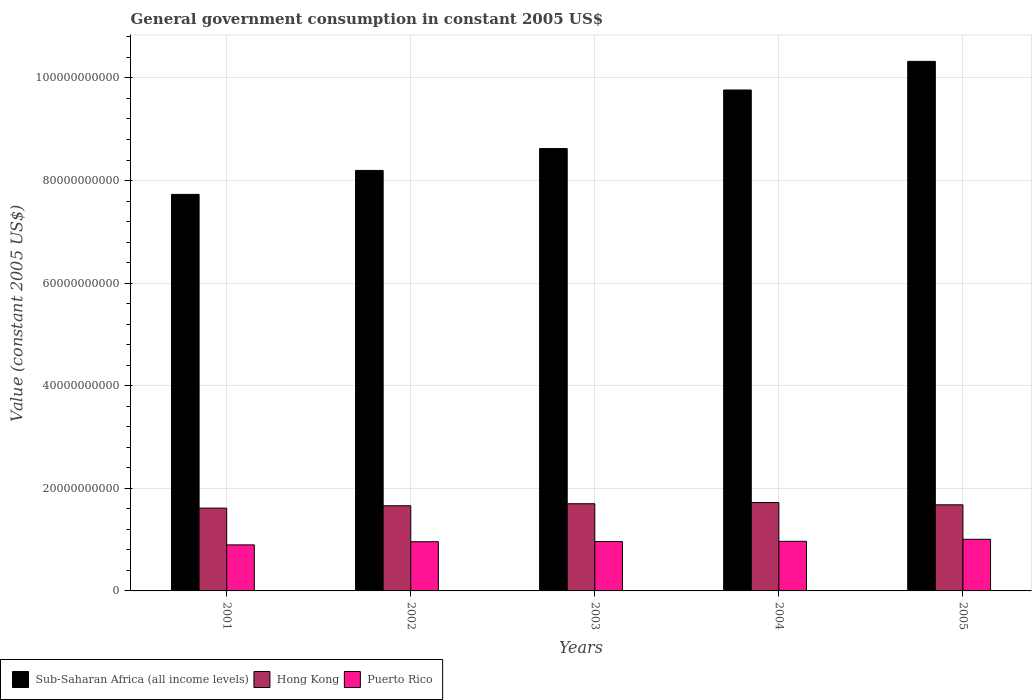How many bars are there on the 1st tick from the left?
Offer a very short reply. 3. What is the label of the 3rd group of bars from the left?
Provide a succinct answer. 2003. In how many cases, is the number of bars for a given year not equal to the number of legend labels?
Provide a succinct answer. 0. What is the government conusmption in Sub-Saharan Africa (all income levels) in 2003?
Give a very brief answer. 8.62e+1. Across all years, what is the maximum government conusmption in Sub-Saharan Africa (all income levels)?
Give a very brief answer. 1.03e+11. Across all years, what is the minimum government conusmption in Hong Kong?
Provide a succinct answer. 1.61e+1. In which year was the government conusmption in Sub-Saharan Africa (all income levels) maximum?
Ensure brevity in your answer.  2005. In which year was the government conusmption in Sub-Saharan Africa (all income levels) minimum?
Provide a succinct answer. 2001. What is the total government conusmption in Sub-Saharan Africa (all income levels) in the graph?
Provide a succinct answer. 4.46e+11. What is the difference between the government conusmption in Puerto Rico in 2003 and that in 2005?
Your answer should be very brief. -4.51e+08. What is the difference between the government conusmption in Sub-Saharan Africa (all income levels) in 2005 and the government conusmption in Hong Kong in 2002?
Keep it short and to the point. 8.66e+1. What is the average government conusmption in Hong Kong per year?
Give a very brief answer. 1.68e+1. In the year 2001, what is the difference between the government conusmption in Hong Kong and government conusmption in Puerto Rico?
Give a very brief answer. 7.16e+09. In how many years, is the government conusmption in Hong Kong greater than 104000000000 US$?
Your answer should be very brief. 0. What is the ratio of the government conusmption in Puerto Rico in 2002 to that in 2005?
Your answer should be very brief. 0.95. What is the difference between the highest and the second highest government conusmption in Puerto Rico?
Ensure brevity in your answer.  3.96e+08. What is the difference between the highest and the lowest government conusmption in Puerto Rico?
Your response must be concise. 1.09e+09. In how many years, is the government conusmption in Puerto Rico greater than the average government conusmption in Puerto Rico taken over all years?
Provide a succinct answer. 4. Is the sum of the government conusmption in Puerto Rico in 2003 and 2004 greater than the maximum government conusmption in Hong Kong across all years?
Your response must be concise. Yes. What does the 2nd bar from the left in 2001 represents?
Offer a terse response. Hong Kong. What does the 3rd bar from the right in 2003 represents?
Keep it short and to the point. Sub-Saharan Africa (all income levels). How many bars are there?
Give a very brief answer. 15. Are all the bars in the graph horizontal?
Your response must be concise. No. Does the graph contain any zero values?
Ensure brevity in your answer.  No. Where does the legend appear in the graph?
Offer a terse response. Bottom left. What is the title of the graph?
Provide a succinct answer. General government consumption in constant 2005 US$. Does "El Salvador" appear as one of the legend labels in the graph?
Ensure brevity in your answer.  No. What is the label or title of the X-axis?
Your answer should be very brief. Years. What is the label or title of the Y-axis?
Keep it short and to the point. Value (constant 2005 US$). What is the Value (constant 2005 US$) in Sub-Saharan Africa (all income levels) in 2001?
Your answer should be very brief. 7.73e+1. What is the Value (constant 2005 US$) in Hong Kong in 2001?
Offer a very short reply. 1.61e+1. What is the Value (constant 2005 US$) in Puerto Rico in 2001?
Offer a very short reply. 8.97e+09. What is the Value (constant 2005 US$) of Sub-Saharan Africa (all income levels) in 2002?
Your response must be concise. 8.20e+1. What is the Value (constant 2005 US$) in Hong Kong in 2002?
Give a very brief answer. 1.66e+1. What is the Value (constant 2005 US$) in Puerto Rico in 2002?
Offer a very short reply. 9.59e+09. What is the Value (constant 2005 US$) of Sub-Saharan Africa (all income levels) in 2003?
Keep it short and to the point. 8.62e+1. What is the Value (constant 2005 US$) in Hong Kong in 2003?
Ensure brevity in your answer.  1.70e+1. What is the Value (constant 2005 US$) in Puerto Rico in 2003?
Ensure brevity in your answer.  9.61e+09. What is the Value (constant 2005 US$) in Sub-Saharan Africa (all income levels) in 2004?
Give a very brief answer. 9.77e+1. What is the Value (constant 2005 US$) of Hong Kong in 2004?
Provide a short and direct response. 1.72e+1. What is the Value (constant 2005 US$) of Puerto Rico in 2004?
Offer a terse response. 9.67e+09. What is the Value (constant 2005 US$) in Sub-Saharan Africa (all income levels) in 2005?
Your response must be concise. 1.03e+11. What is the Value (constant 2005 US$) in Hong Kong in 2005?
Your response must be concise. 1.68e+1. What is the Value (constant 2005 US$) in Puerto Rico in 2005?
Give a very brief answer. 1.01e+1. Across all years, what is the maximum Value (constant 2005 US$) of Sub-Saharan Africa (all income levels)?
Offer a terse response. 1.03e+11. Across all years, what is the maximum Value (constant 2005 US$) of Hong Kong?
Keep it short and to the point. 1.72e+1. Across all years, what is the maximum Value (constant 2005 US$) in Puerto Rico?
Make the answer very short. 1.01e+1. Across all years, what is the minimum Value (constant 2005 US$) in Sub-Saharan Africa (all income levels)?
Give a very brief answer. 7.73e+1. Across all years, what is the minimum Value (constant 2005 US$) in Hong Kong?
Offer a terse response. 1.61e+1. Across all years, what is the minimum Value (constant 2005 US$) in Puerto Rico?
Make the answer very short. 8.97e+09. What is the total Value (constant 2005 US$) of Sub-Saharan Africa (all income levels) in the graph?
Provide a short and direct response. 4.46e+11. What is the total Value (constant 2005 US$) of Hong Kong in the graph?
Your answer should be very brief. 8.38e+1. What is the total Value (constant 2005 US$) of Puerto Rico in the graph?
Keep it short and to the point. 4.79e+1. What is the difference between the Value (constant 2005 US$) in Sub-Saharan Africa (all income levels) in 2001 and that in 2002?
Make the answer very short. -4.67e+09. What is the difference between the Value (constant 2005 US$) of Hong Kong in 2001 and that in 2002?
Make the answer very short. -4.63e+08. What is the difference between the Value (constant 2005 US$) in Puerto Rico in 2001 and that in 2002?
Your answer should be compact. -6.16e+08. What is the difference between the Value (constant 2005 US$) of Sub-Saharan Africa (all income levels) in 2001 and that in 2003?
Your answer should be compact. -8.93e+09. What is the difference between the Value (constant 2005 US$) in Hong Kong in 2001 and that in 2003?
Make the answer very short. -8.58e+08. What is the difference between the Value (constant 2005 US$) in Puerto Rico in 2001 and that in 2003?
Your answer should be very brief. -6.41e+08. What is the difference between the Value (constant 2005 US$) of Sub-Saharan Africa (all income levels) in 2001 and that in 2004?
Offer a very short reply. -2.03e+1. What is the difference between the Value (constant 2005 US$) of Hong Kong in 2001 and that in 2004?
Your answer should be very brief. -1.09e+09. What is the difference between the Value (constant 2005 US$) in Puerto Rico in 2001 and that in 2004?
Your answer should be compact. -6.96e+08. What is the difference between the Value (constant 2005 US$) in Sub-Saharan Africa (all income levels) in 2001 and that in 2005?
Your response must be concise. -2.59e+1. What is the difference between the Value (constant 2005 US$) of Hong Kong in 2001 and that in 2005?
Give a very brief answer. -6.51e+08. What is the difference between the Value (constant 2005 US$) in Puerto Rico in 2001 and that in 2005?
Provide a short and direct response. -1.09e+09. What is the difference between the Value (constant 2005 US$) in Sub-Saharan Africa (all income levels) in 2002 and that in 2003?
Offer a very short reply. -4.26e+09. What is the difference between the Value (constant 2005 US$) of Hong Kong in 2002 and that in 2003?
Provide a short and direct response. -3.95e+08. What is the difference between the Value (constant 2005 US$) in Puerto Rico in 2002 and that in 2003?
Provide a short and direct response. -2.49e+07. What is the difference between the Value (constant 2005 US$) of Sub-Saharan Africa (all income levels) in 2002 and that in 2004?
Your response must be concise. -1.57e+1. What is the difference between the Value (constant 2005 US$) in Hong Kong in 2002 and that in 2004?
Make the answer very short. -6.30e+08. What is the difference between the Value (constant 2005 US$) of Puerto Rico in 2002 and that in 2004?
Your answer should be compact. -7.96e+07. What is the difference between the Value (constant 2005 US$) of Sub-Saharan Africa (all income levels) in 2002 and that in 2005?
Offer a very short reply. -2.13e+1. What is the difference between the Value (constant 2005 US$) in Hong Kong in 2002 and that in 2005?
Offer a terse response. -1.88e+08. What is the difference between the Value (constant 2005 US$) of Puerto Rico in 2002 and that in 2005?
Ensure brevity in your answer.  -4.76e+08. What is the difference between the Value (constant 2005 US$) of Sub-Saharan Africa (all income levels) in 2003 and that in 2004?
Give a very brief answer. -1.14e+1. What is the difference between the Value (constant 2005 US$) in Hong Kong in 2003 and that in 2004?
Your response must be concise. -2.36e+08. What is the difference between the Value (constant 2005 US$) in Puerto Rico in 2003 and that in 2004?
Ensure brevity in your answer.  -5.46e+07. What is the difference between the Value (constant 2005 US$) in Sub-Saharan Africa (all income levels) in 2003 and that in 2005?
Offer a terse response. -1.70e+1. What is the difference between the Value (constant 2005 US$) of Hong Kong in 2003 and that in 2005?
Make the answer very short. 2.07e+08. What is the difference between the Value (constant 2005 US$) of Puerto Rico in 2003 and that in 2005?
Offer a terse response. -4.51e+08. What is the difference between the Value (constant 2005 US$) of Sub-Saharan Africa (all income levels) in 2004 and that in 2005?
Your answer should be compact. -5.58e+09. What is the difference between the Value (constant 2005 US$) of Hong Kong in 2004 and that in 2005?
Ensure brevity in your answer.  4.43e+08. What is the difference between the Value (constant 2005 US$) of Puerto Rico in 2004 and that in 2005?
Your answer should be compact. -3.96e+08. What is the difference between the Value (constant 2005 US$) of Sub-Saharan Africa (all income levels) in 2001 and the Value (constant 2005 US$) of Hong Kong in 2002?
Provide a succinct answer. 6.07e+1. What is the difference between the Value (constant 2005 US$) in Sub-Saharan Africa (all income levels) in 2001 and the Value (constant 2005 US$) in Puerto Rico in 2002?
Give a very brief answer. 6.77e+1. What is the difference between the Value (constant 2005 US$) of Hong Kong in 2001 and the Value (constant 2005 US$) of Puerto Rico in 2002?
Offer a very short reply. 6.55e+09. What is the difference between the Value (constant 2005 US$) of Sub-Saharan Africa (all income levels) in 2001 and the Value (constant 2005 US$) of Hong Kong in 2003?
Your answer should be compact. 6.03e+1. What is the difference between the Value (constant 2005 US$) in Sub-Saharan Africa (all income levels) in 2001 and the Value (constant 2005 US$) in Puerto Rico in 2003?
Your answer should be compact. 6.77e+1. What is the difference between the Value (constant 2005 US$) of Hong Kong in 2001 and the Value (constant 2005 US$) of Puerto Rico in 2003?
Keep it short and to the point. 6.52e+09. What is the difference between the Value (constant 2005 US$) of Sub-Saharan Africa (all income levels) in 2001 and the Value (constant 2005 US$) of Hong Kong in 2004?
Provide a succinct answer. 6.01e+1. What is the difference between the Value (constant 2005 US$) of Sub-Saharan Africa (all income levels) in 2001 and the Value (constant 2005 US$) of Puerto Rico in 2004?
Keep it short and to the point. 6.76e+1. What is the difference between the Value (constant 2005 US$) in Hong Kong in 2001 and the Value (constant 2005 US$) in Puerto Rico in 2004?
Your answer should be compact. 6.47e+09. What is the difference between the Value (constant 2005 US$) of Sub-Saharan Africa (all income levels) in 2001 and the Value (constant 2005 US$) of Hong Kong in 2005?
Offer a terse response. 6.05e+1. What is the difference between the Value (constant 2005 US$) in Sub-Saharan Africa (all income levels) in 2001 and the Value (constant 2005 US$) in Puerto Rico in 2005?
Offer a very short reply. 6.72e+1. What is the difference between the Value (constant 2005 US$) of Hong Kong in 2001 and the Value (constant 2005 US$) of Puerto Rico in 2005?
Provide a short and direct response. 6.07e+09. What is the difference between the Value (constant 2005 US$) in Sub-Saharan Africa (all income levels) in 2002 and the Value (constant 2005 US$) in Hong Kong in 2003?
Offer a very short reply. 6.50e+1. What is the difference between the Value (constant 2005 US$) in Sub-Saharan Africa (all income levels) in 2002 and the Value (constant 2005 US$) in Puerto Rico in 2003?
Keep it short and to the point. 7.24e+1. What is the difference between the Value (constant 2005 US$) in Hong Kong in 2002 and the Value (constant 2005 US$) in Puerto Rico in 2003?
Provide a succinct answer. 6.99e+09. What is the difference between the Value (constant 2005 US$) in Sub-Saharan Africa (all income levels) in 2002 and the Value (constant 2005 US$) in Hong Kong in 2004?
Offer a terse response. 6.47e+1. What is the difference between the Value (constant 2005 US$) of Sub-Saharan Africa (all income levels) in 2002 and the Value (constant 2005 US$) of Puerto Rico in 2004?
Ensure brevity in your answer.  7.23e+1. What is the difference between the Value (constant 2005 US$) in Hong Kong in 2002 and the Value (constant 2005 US$) in Puerto Rico in 2004?
Keep it short and to the point. 6.93e+09. What is the difference between the Value (constant 2005 US$) of Sub-Saharan Africa (all income levels) in 2002 and the Value (constant 2005 US$) of Hong Kong in 2005?
Make the answer very short. 6.52e+1. What is the difference between the Value (constant 2005 US$) in Sub-Saharan Africa (all income levels) in 2002 and the Value (constant 2005 US$) in Puerto Rico in 2005?
Make the answer very short. 7.19e+1. What is the difference between the Value (constant 2005 US$) in Hong Kong in 2002 and the Value (constant 2005 US$) in Puerto Rico in 2005?
Offer a very short reply. 6.54e+09. What is the difference between the Value (constant 2005 US$) of Sub-Saharan Africa (all income levels) in 2003 and the Value (constant 2005 US$) of Hong Kong in 2004?
Make the answer very short. 6.90e+1. What is the difference between the Value (constant 2005 US$) of Sub-Saharan Africa (all income levels) in 2003 and the Value (constant 2005 US$) of Puerto Rico in 2004?
Ensure brevity in your answer.  7.66e+1. What is the difference between the Value (constant 2005 US$) of Hong Kong in 2003 and the Value (constant 2005 US$) of Puerto Rico in 2004?
Provide a succinct answer. 7.33e+09. What is the difference between the Value (constant 2005 US$) in Sub-Saharan Africa (all income levels) in 2003 and the Value (constant 2005 US$) in Hong Kong in 2005?
Give a very brief answer. 6.94e+1. What is the difference between the Value (constant 2005 US$) of Sub-Saharan Africa (all income levels) in 2003 and the Value (constant 2005 US$) of Puerto Rico in 2005?
Your response must be concise. 7.62e+1. What is the difference between the Value (constant 2005 US$) of Hong Kong in 2003 and the Value (constant 2005 US$) of Puerto Rico in 2005?
Keep it short and to the point. 6.93e+09. What is the difference between the Value (constant 2005 US$) of Sub-Saharan Africa (all income levels) in 2004 and the Value (constant 2005 US$) of Hong Kong in 2005?
Ensure brevity in your answer.  8.09e+1. What is the difference between the Value (constant 2005 US$) in Sub-Saharan Africa (all income levels) in 2004 and the Value (constant 2005 US$) in Puerto Rico in 2005?
Make the answer very short. 8.76e+1. What is the difference between the Value (constant 2005 US$) of Hong Kong in 2004 and the Value (constant 2005 US$) of Puerto Rico in 2005?
Provide a succinct answer. 7.17e+09. What is the average Value (constant 2005 US$) in Sub-Saharan Africa (all income levels) per year?
Give a very brief answer. 8.93e+1. What is the average Value (constant 2005 US$) in Hong Kong per year?
Ensure brevity in your answer.  1.68e+1. What is the average Value (constant 2005 US$) in Puerto Rico per year?
Your answer should be very brief. 9.58e+09. In the year 2001, what is the difference between the Value (constant 2005 US$) in Sub-Saharan Africa (all income levels) and Value (constant 2005 US$) in Hong Kong?
Provide a short and direct response. 6.12e+1. In the year 2001, what is the difference between the Value (constant 2005 US$) of Sub-Saharan Africa (all income levels) and Value (constant 2005 US$) of Puerto Rico?
Offer a very short reply. 6.83e+1. In the year 2001, what is the difference between the Value (constant 2005 US$) of Hong Kong and Value (constant 2005 US$) of Puerto Rico?
Provide a short and direct response. 7.16e+09. In the year 2002, what is the difference between the Value (constant 2005 US$) of Sub-Saharan Africa (all income levels) and Value (constant 2005 US$) of Hong Kong?
Provide a short and direct response. 6.54e+1. In the year 2002, what is the difference between the Value (constant 2005 US$) in Sub-Saharan Africa (all income levels) and Value (constant 2005 US$) in Puerto Rico?
Ensure brevity in your answer.  7.24e+1. In the year 2002, what is the difference between the Value (constant 2005 US$) in Hong Kong and Value (constant 2005 US$) in Puerto Rico?
Make the answer very short. 7.01e+09. In the year 2003, what is the difference between the Value (constant 2005 US$) of Sub-Saharan Africa (all income levels) and Value (constant 2005 US$) of Hong Kong?
Ensure brevity in your answer.  6.92e+1. In the year 2003, what is the difference between the Value (constant 2005 US$) of Sub-Saharan Africa (all income levels) and Value (constant 2005 US$) of Puerto Rico?
Provide a short and direct response. 7.66e+1. In the year 2003, what is the difference between the Value (constant 2005 US$) in Hong Kong and Value (constant 2005 US$) in Puerto Rico?
Give a very brief answer. 7.38e+09. In the year 2004, what is the difference between the Value (constant 2005 US$) in Sub-Saharan Africa (all income levels) and Value (constant 2005 US$) in Hong Kong?
Your response must be concise. 8.04e+1. In the year 2004, what is the difference between the Value (constant 2005 US$) in Sub-Saharan Africa (all income levels) and Value (constant 2005 US$) in Puerto Rico?
Make the answer very short. 8.80e+1. In the year 2004, what is the difference between the Value (constant 2005 US$) in Hong Kong and Value (constant 2005 US$) in Puerto Rico?
Provide a short and direct response. 7.56e+09. In the year 2005, what is the difference between the Value (constant 2005 US$) in Sub-Saharan Africa (all income levels) and Value (constant 2005 US$) in Hong Kong?
Provide a succinct answer. 8.64e+1. In the year 2005, what is the difference between the Value (constant 2005 US$) in Sub-Saharan Africa (all income levels) and Value (constant 2005 US$) in Puerto Rico?
Provide a succinct answer. 9.32e+1. In the year 2005, what is the difference between the Value (constant 2005 US$) of Hong Kong and Value (constant 2005 US$) of Puerto Rico?
Ensure brevity in your answer.  6.72e+09. What is the ratio of the Value (constant 2005 US$) in Sub-Saharan Africa (all income levels) in 2001 to that in 2002?
Keep it short and to the point. 0.94. What is the ratio of the Value (constant 2005 US$) of Hong Kong in 2001 to that in 2002?
Your answer should be compact. 0.97. What is the ratio of the Value (constant 2005 US$) of Puerto Rico in 2001 to that in 2002?
Give a very brief answer. 0.94. What is the ratio of the Value (constant 2005 US$) in Sub-Saharan Africa (all income levels) in 2001 to that in 2003?
Your answer should be very brief. 0.9. What is the ratio of the Value (constant 2005 US$) of Hong Kong in 2001 to that in 2003?
Offer a terse response. 0.95. What is the ratio of the Value (constant 2005 US$) in Puerto Rico in 2001 to that in 2003?
Give a very brief answer. 0.93. What is the ratio of the Value (constant 2005 US$) of Sub-Saharan Africa (all income levels) in 2001 to that in 2004?
Provide a succinct answer. 0.79. What is the ratio of the Value (constant 2005 US$) of Hong Kong in 2001 to that in 2004?
Give a very brief answer. 0.94. What is the ratio of the Value (constant 2005 US$) in Puerto Rico in 2001 to that in 2004?
Your answer should be very brief. 0.93. What is the ratio of the Value (constant 2005 US$) of Sub-Saharan Africa (all income levels) in 2001 to that in 2005?
Ensure brevity in your answer.  0.75. What is the ratio of the Value (constant 2005 US$) of Hong Kong in 2001 to that in 2005?
Provide a succinct answer. 0.96. What is the ratio of the Value (constant 2005 US$) in Puerto Rico in 2001 to that in 2005?
Make the answer very short. 0.89. What is the ratio of the Value (constant 2005 US$) in Sub-Saharan Africa (all income levels) in 2002 to that in 2003?
Offer a very short reply. 0.95. What is the ratio of the Value (constant 2005 US$) of Hong Kong in 2002 to that in 2003?
Give a very brief answer. 0.98. What is the ratio of the Value (constant 2005 US$) of Sub-Saharan Africa (all income levels) in 2002 to that in 2004?
Offer a terse response. 0.84. What is the ratio of the Value (constant 2005 US$) in Hong Kong in 2002 to that in 2004?
Provide a short and direct response. 0.96. What is the ratio of the Value (constant 2005 US$) of Puerto Rico in 2002 to that in 2004?
Your answer should be very brief. 0.99. What is the ratio of the Value (constant 2005 US$) of Sub-Saharan Africa (all income levels) in 2002 to that in 2005?
Offer a terse response. 0.79. What is the ratio of the Value (constant 2005 US$) of Hong Kong in 2002 to that in 2005?
Make the answer very short. 0.99. What is the ratio of the Value (constant 2005 US$) of Puerto Rico in 2002 to that in 2005?
Provide a short and direct response. 0.95. What is the ratio of the Value (constant 2005 US$) in Sub-Saharan Africa (all income levels) in 2003 to that in 2004?
Give a very brief answer. 0.88. What is the ratio of the Value (constant 2005 US$) in Hong Kong in 2003 to that in 2004?
Your answer should be very brief. 0.99. What is the ratio of the Value (constant 2005 US$) of Puerto Rico in 2003 to that in 2004?
Your answer should be compact. 0.99. What is the ratio of the Value (constant 2005 US$) of Sub-Saharan Africa (all income levels) in 2003 to that in 2005?
Your answer should be very brief. 0.84. What is the ratio of the Value (constant 2005 US$) in Hong Kong in 2003 to that in 2005?
Provide a succinct answer. 1.01. What is the ratio of the Value (constant 2005 US$) of Puerto Rico in 2003 to that in 2005?
Ensure brevity in your answer.  0.96. What is the ratio of the Value (constant 2005 US$) of Sub-Saharan Africa (all income levels) in 2004 to that in 2005?
Make the answer very short. 0.95. What is the ratio of the Value (constant 2005 US$) in Hong Kong in 2004 to that in 2005?
Make the answer very short. 1.03. What is the ratio of the Value (constant 2005 US$) in Puerto Rico in 2004 to that in 2005?
Your answer should be compact. 0.96. What is the difference between the highest and the second highest Value (constant 2005 US$) in Sub-Saharan Africa (all income levels)?
Make the answer very short. 5.58e+09. What is the difference between the highest and the second highest Value (constant 2005 US$) in Hong Kong?
Provide a succinct answer. 2.36e+08. What is the difference between the highest and the second highest Value (constant 2005 US$) in Puerto Rico?
Your answer should be very brief. 3.96e+08. What is the difference between the highest and the lowest Value (constant 2005 US$) of Sub-Saharan Africa (all income levels)?
Offer a very short reply. 2.59e+1. What is the difference between the highest and the lowest Value (constant 2005 US$) of Hong Kong?
Keep it short and to the point. 1.09e+09. What is the difference between the highest and the lowest Value (constant 2005 US$) of Puerto Rico?
Make the answer very short. 1.09e+09. 